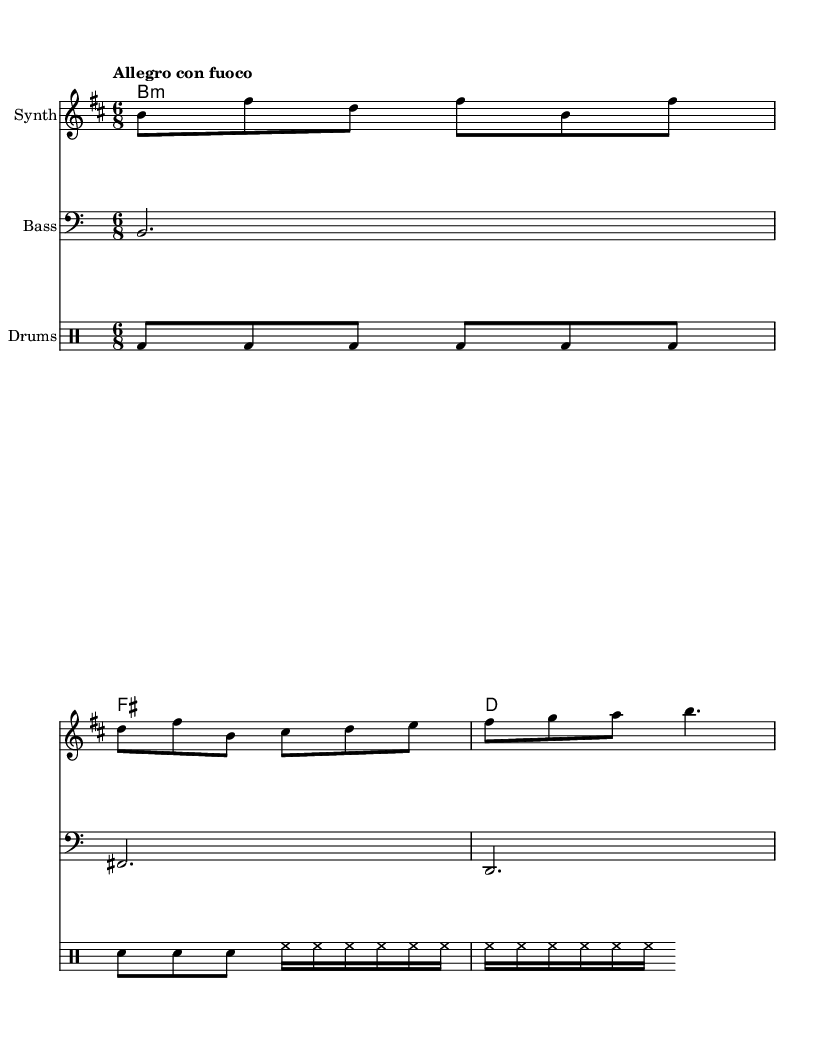What is the key signature of this music? The key signature is indicated at the beginning of the staff, showing B minor, which has two sharps (F# and C#).
Answer: B minor What is the time signature of this music? The time signature is located at the start of the staff and is noted as 6/8, which indicates six eighth-note beats in each measure.
Answer: 6/8 What is the tempo marking for this piece? The tempo marking "Allegro con fuoco" appears at the beginning and suggests a fast pace with fire or intensity.
Answer: Allegro con fuoco How many measures are in the melody line? By counting the individual segments of music separated by vertical lines (bar lines) in the melody, there are four measures.
Answer: Four What instruments are featured in this score? The score contains a Synth for the melody, a Bass, and a DrumStaff for percussion, as indicated in the staff names.
Answer: Synth, Bass, Drums What type of music is this piece categorized as? The sheet indicates an opera, as suggested by the context of the modernized productions and the nature of the material.
Answer: Opera What is the last note in the melody line? The last note in the melody is identified by observing the final note in the melody staff, which is a B.
Answer: B 